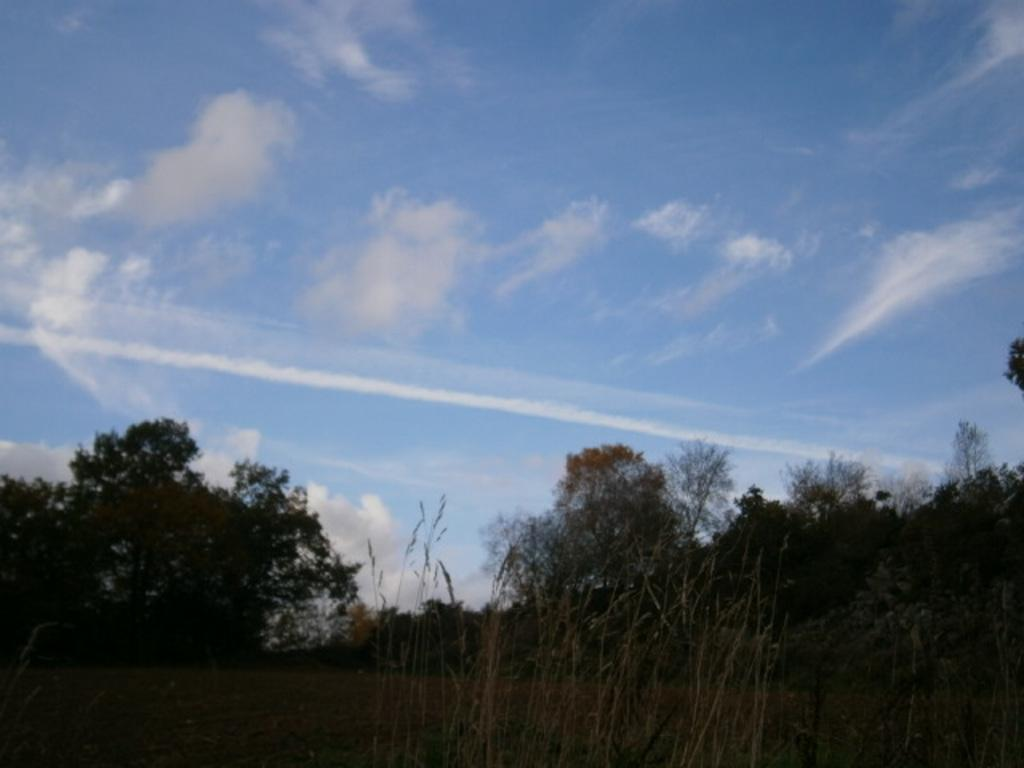What type of vegetation is visible at the bottom side of the image? There are trees at the bottom side of the image. What natural element is visible at the top side of the image? There is sky at the top side of the image. Where is the cherry located in the image? There is no cherry present in the image. What type of drain is visible in the image? There is no drain present in the image. 